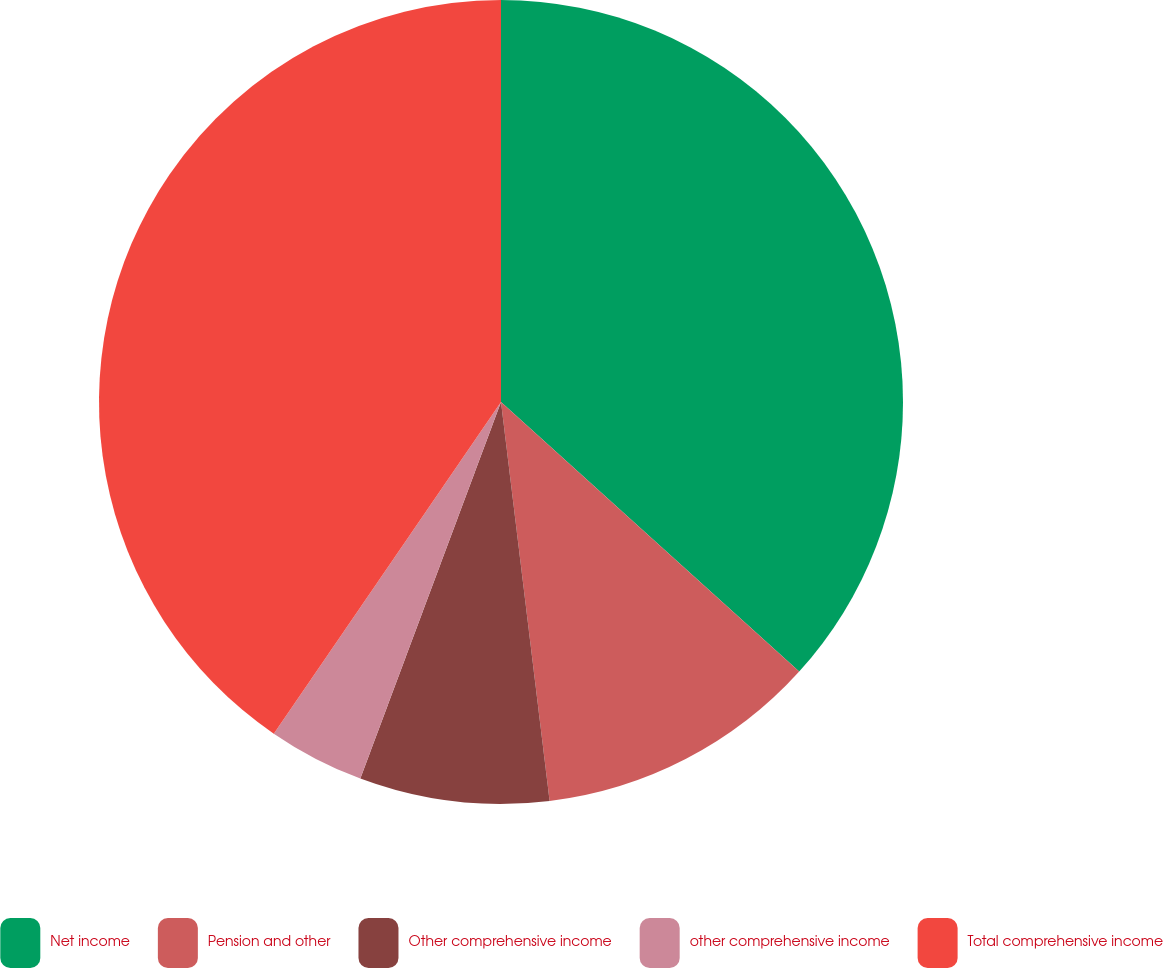Convert chart. <chart><loc_0><loc_0><loc_500><loc_500><pie_chart><fcel>Net income<fcel>Pension and other<fcel>Other comprehensive income<fcel>other comprehensive income<fcel>Total comprehensive income<nl><fcel>36.7%<fcel>11.37%<fcel>7.62%<fcel>3.87%<fcel>40.44%<nl></chart> 